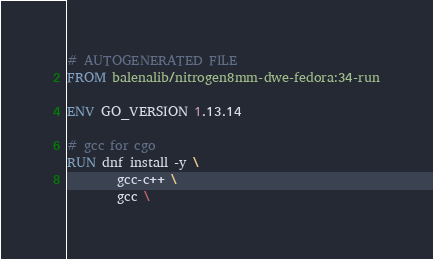Convert code to text. <code><loc_0><loc_0><loc_500><loc_500><_Dockerfile_># AUTOGENERATED FILE
FROM balenalib/nitrogen8mm-dwe-fedora:34-run

ENV GO_VERSION 1.13.14

# gcc for cgo
RUN dnf install -y \
		gcc-c++ \
		gcc \</code> 